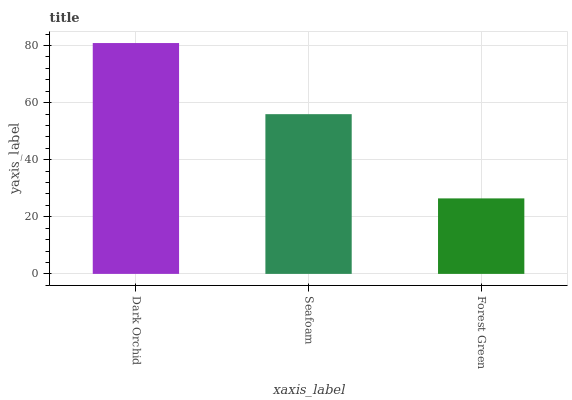Is Forest Green the minimum?
Answer yes or no. Yes. Is Dark Orchid the maximum?
Answer yes or no. Yes. Is Seafoam the minimum?
Answer yes or no. No. Is Seafoam the maximum?
Answer yes or no. No. Is Dark Orchid greater than Seafoam?
Answer yes or no. Yes. Is Seafoam less than Dark Orchid?
Answer yes or no. Yes. Is Seafoam greater than Dark Orchid?
Answer yes or no. No. Is Dark Orchid less than Seafoam?
Answer yes or no. No. Is Seafoam the high median?
Answer yes or no. Yes. Is Seafoam the low median?
Answer yes or no. Yes. Is Forest Green the high median?
Answer yes or no. No. Is Dark Orchid the low median?
Answer yes or no. No. 